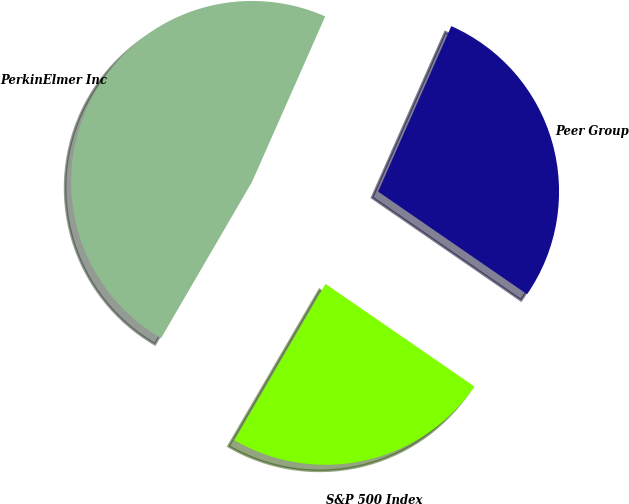Convert chart to OTSL. <chart><loc_0><loc_0><loc_500><loc_500><pie_chart><fcel>PerkinElmer Inc<fcel>S&P 500 Index<fcel>Peer Group<nl><fcel>48.24%<fcel>23.79%<fcel>27.98%<nl></chart> 